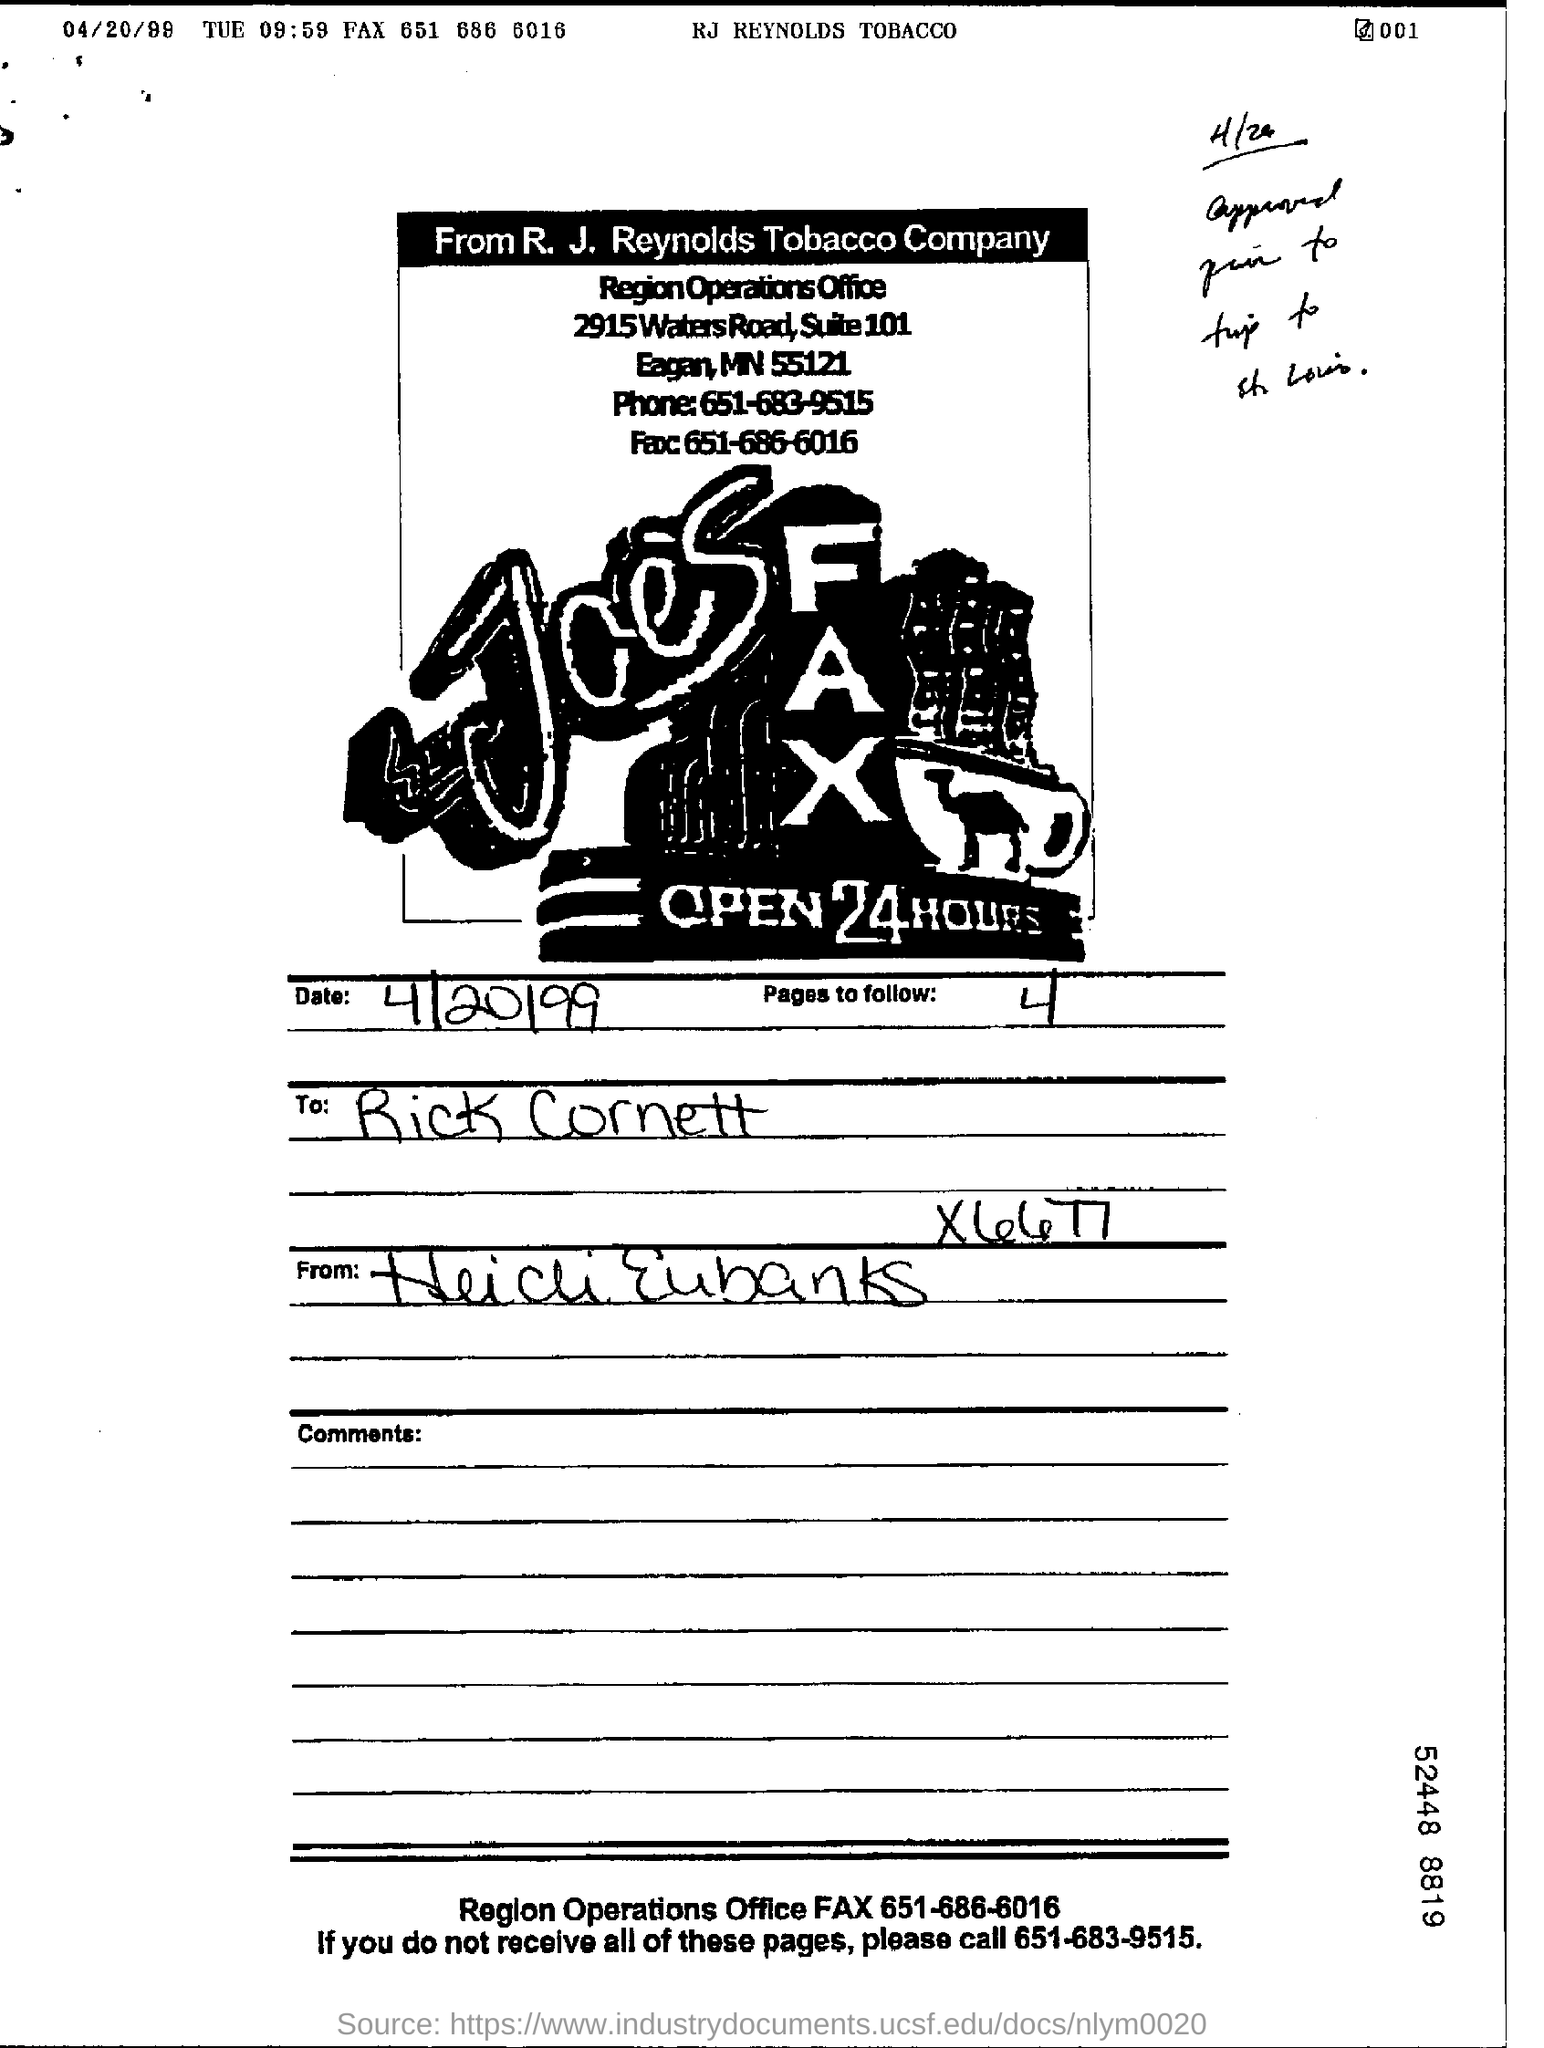Draw attention to some important aspects in this diagram. I will follow a total of 4 pages. 